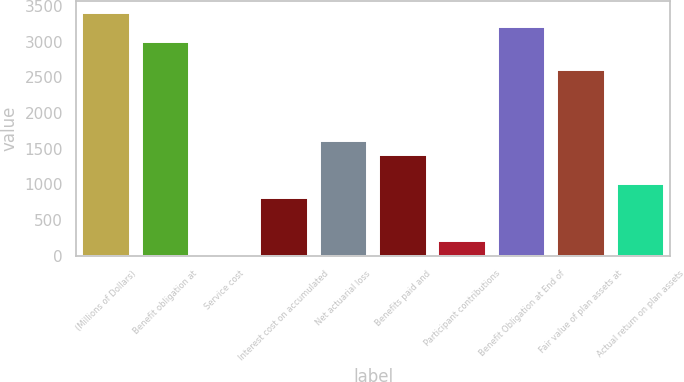Convert chart. <chart><loc_0><loc_0><loc_500><loc_500><bar_chart><fcel>(Millions of Dollars)<fcel>Benefit obligation at<fcel>Service cost<fcel>Interest cost on accumulated<fcel>Net actuarial loss<fcel>Benefits paid and<fcel>Participant contributions<fcel>Benefit Obligation at End of<fcel>Fair value of plan assets at<fcel>Actual return on plan assets<nl><fcel>3399.1<fcel>3000.5<fcel>11<fcel>808.2<fcel>1605.4<fcel>1406.1<fcel>210.3<fcel>3199.8<fcel>2601.9<fcel>1007.5<nl></chart> 